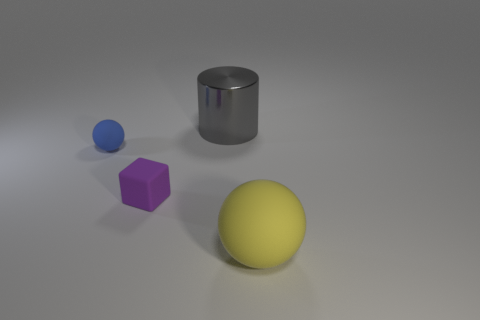Add 3 purple spheres. How many objects exist? 7 Subtract all yellow spheres. How many spheres are left? 1 Subtract all cylinders. How many objects are left? 3 Subtract all cyan spheres. Subtract all red cylinders. How many spheres are left? 2 Add 1 shiny objects. How many shiny objects exist? 2 Subtract 0 purple cylinders. How many objects are left? 4 Subtract all green cylinders. How many blue balls are left? 1 Subtract all blue matte things. Subtract all big matte spheres. How many objects are left? 2 Add 3 cylinders. How many cylinders are left? 4 